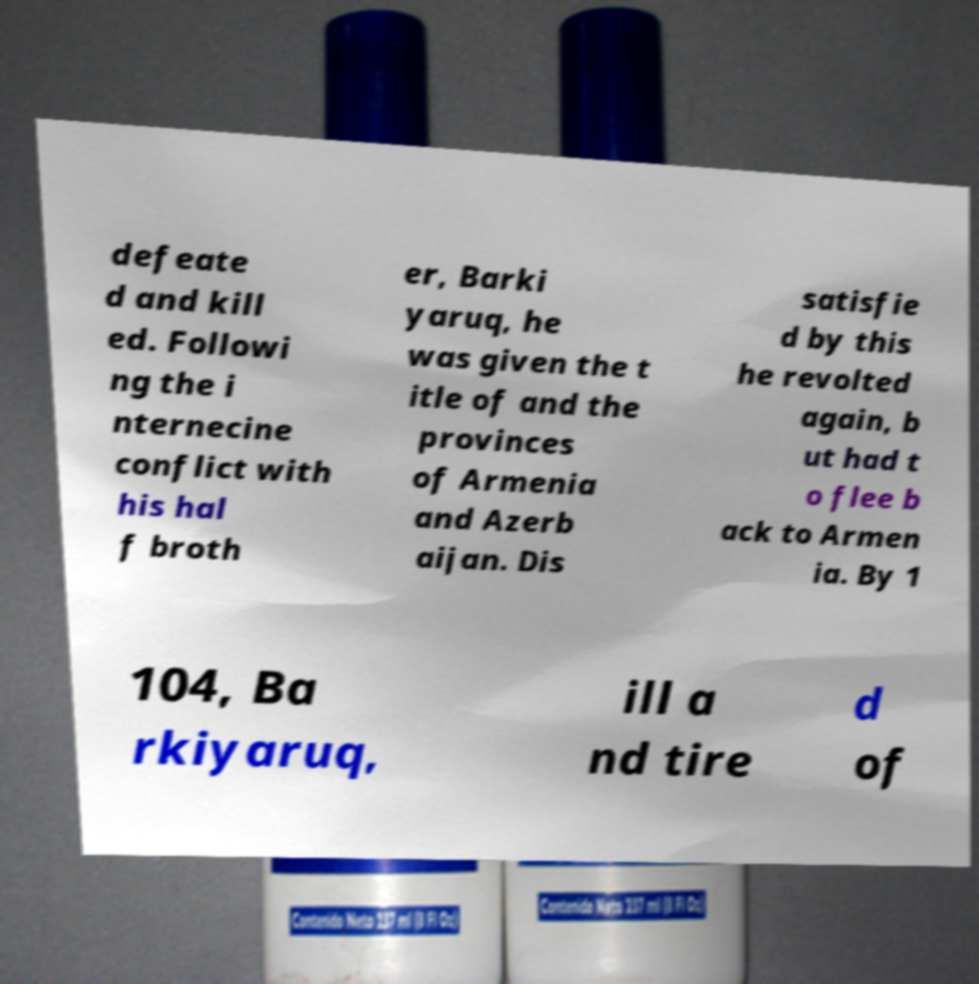For documentation purposes, I need the text within this image transcribed. Could you provide that? defeate d and kill ed. Followi ng the i nternecine conflict with his hal f broth er, Barki yaruq, he was given the t itle of and the provinces of Armenia and Azerb aijan. Dis satisfie d by this he revolted again, b ut had t o flee b ack to Armen ia. By 1 104, Ba rkiyaruq, ill a nd tire d of 